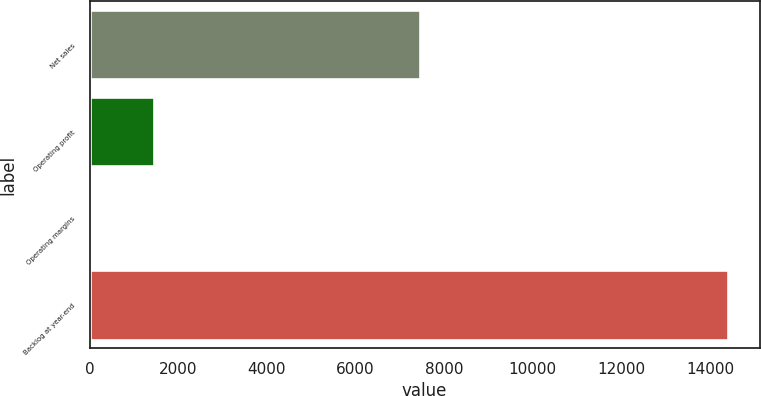Convert chart. <chart><loc_0><loc_0><loc_500><loc_500><bar_chart><fcel>Net sales<fcel>Operating profit<fcel>Operating margins<fcel>Backlog at year-end<nl><fcel>7463<fcel>1452.87<fcel>14.3<fcel>14400<nl></chart> 